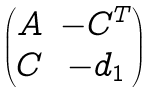Convert formula to latex. <formula><loc_0><loc_0><loc_500><loc_500>\begin{pmatrix} A & - C ^ { T } \\ C & - d _ { 1 } \end{pmatrix}</formula> 